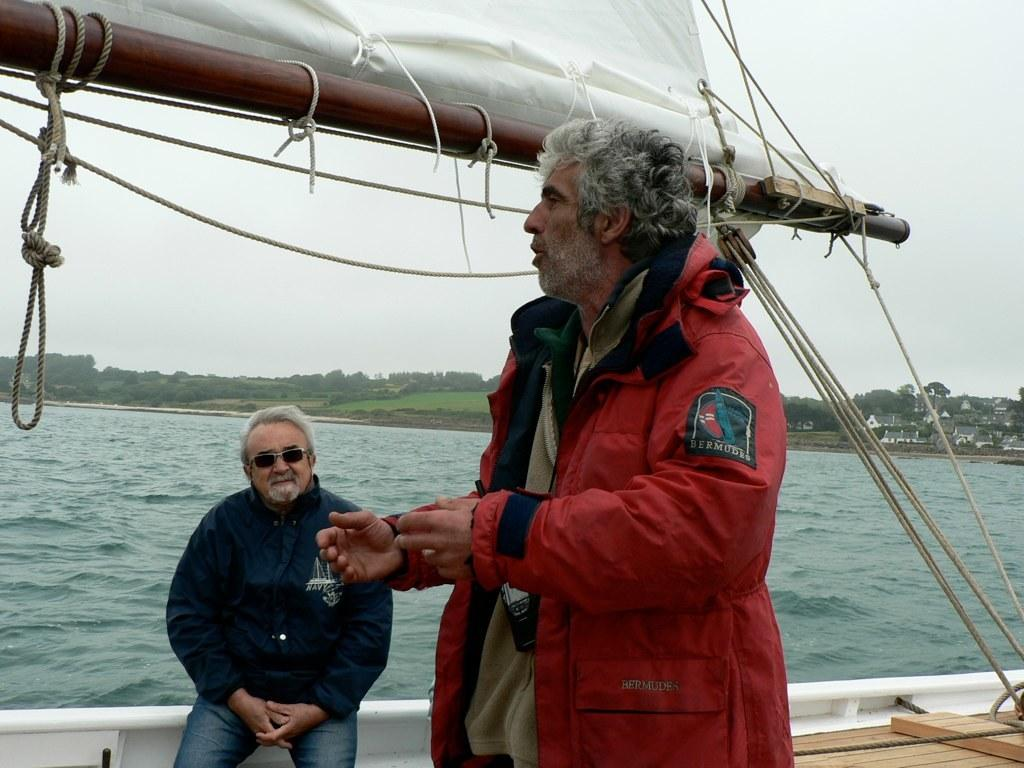<image>
Summarize the visual content of the image. A man wearing a red jacket with a patch on the sleeve that reads Bermudes. 